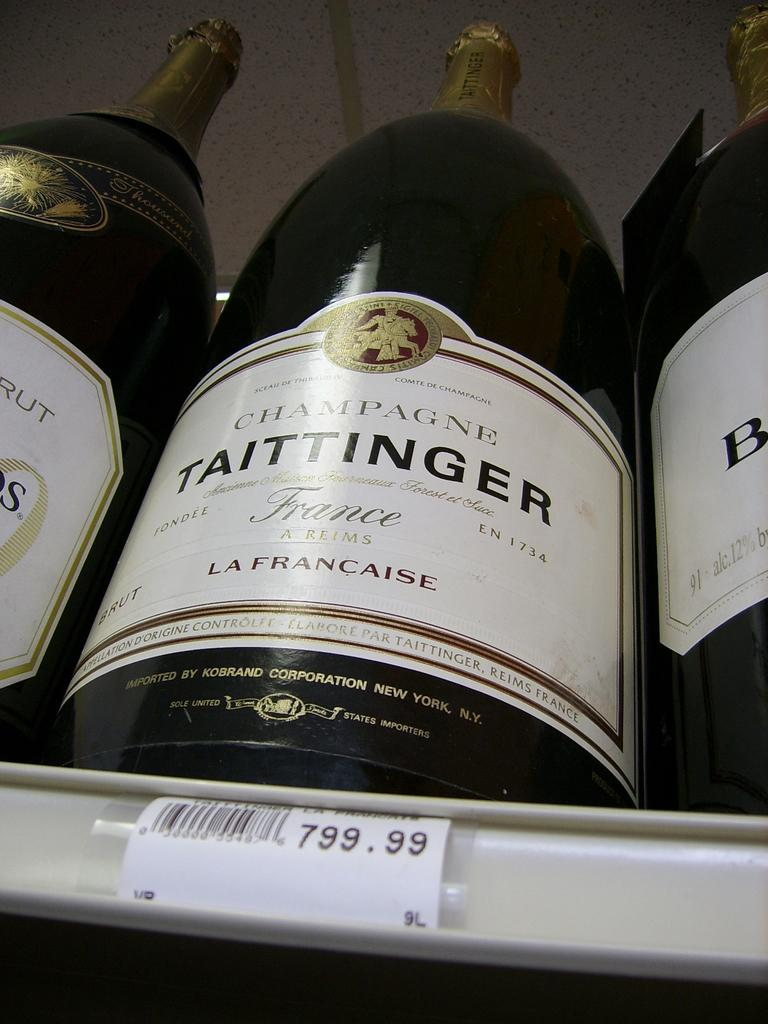<image>
Relay a brief, clear account of the picture shown. A rack of Champagne bottles with a label that says Taittinger on it. 